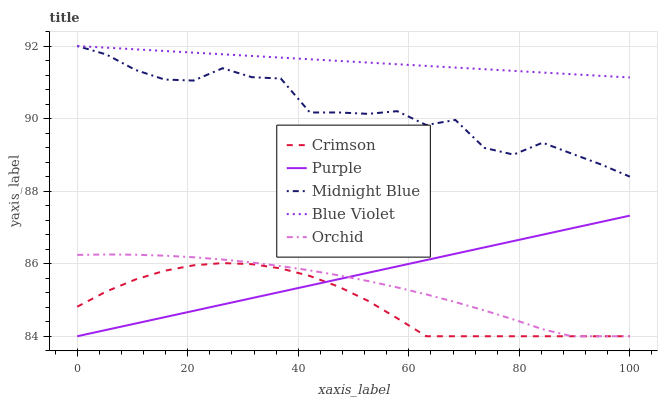Does Crimson have the minimum area under the curve?
Answer yes or no. Yes. Does Blue Violet have the maximum area under the curve?
Answer yes or no. Yes. Does Purple have the minimum area under the curve?
Answer yes or no. No. Does Purple have the maximum area under the curve?
Answer yes or no. No. Is Blue Violet the smoothest?
Answer yes or no. Yes. Is Midnight Blue the roughest?
Answer yes or no. Yes. Is Purple the smoothest?
Answer yes or no. No. Is Purple the roughest?
Answer yes or no. No. Does Crimson have the lowest value?
Answer yes or no. Yes. Does Midnight Blue have the lowest value?
Answer yes or no. No. Does Blue Violet have the highest value?
Answer yes or no. Yes. Does Purple have the highest value?
Answer yes or no. No. Is Crimson less than Midnight Blue?
Answer yes or no. Yes. Is Midnight Blue greater than Orchid?
Answer yes or no. Yes. Does Midnight Blue intersect Blue Violet?
Answer yes or no. Yes. Is Midnight Blue less than Blue Violet?
Answer yes or no. No. Is Midnight Blue greater than Blue Violet?
Answer yes or no. No. Does Crimson intersect Midnight Blue?
Answer yes or no. No. 